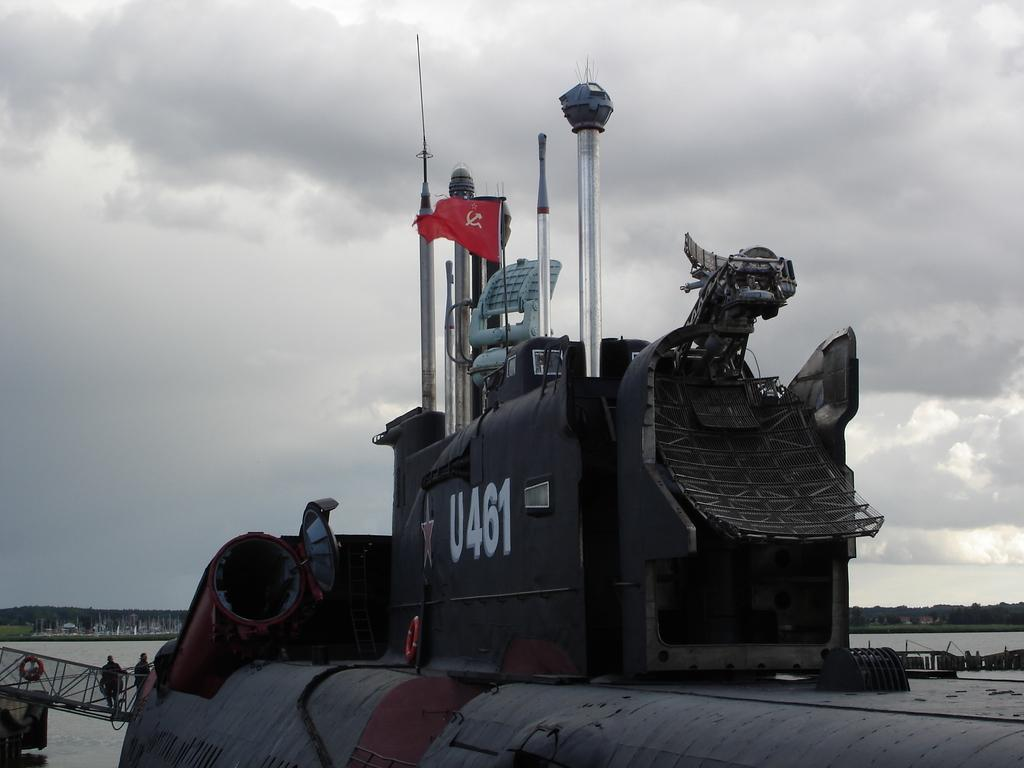What is the main subject of the image? The main subject of the image is a submarine. Can you describe any specific details about the submarine? Yes, the submarine has a number. What else can be seen in the image besides the submarine? There is a flag, water, people, and the sky visible in the image. What is the condition of the sky in the image? The sky is visible in the background of the image, and there are clouds present. What is the reason for the submarine's birth in the image? There is no indication in the image that the submarine has been born, nor is there any information about the submarine's reason for existence. 